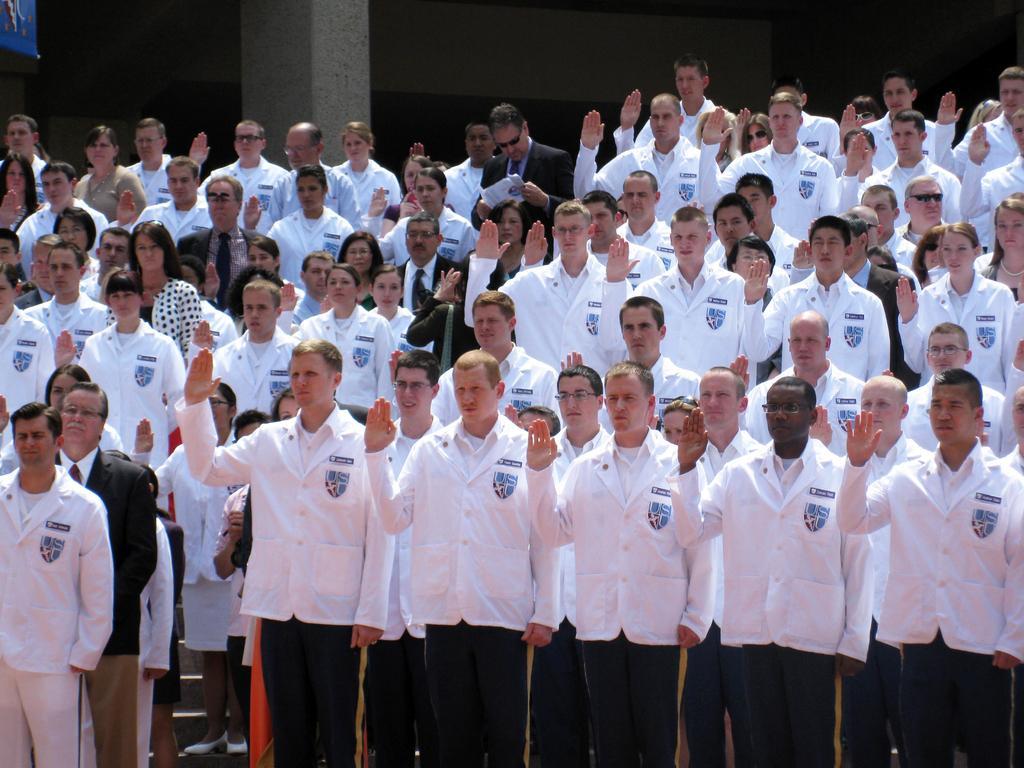How would you summarize this image in a sentence or two? In this picture there are group of people standing. At the back there is a building. At the bottom there is a staircase. There are group of people in white shirts. 